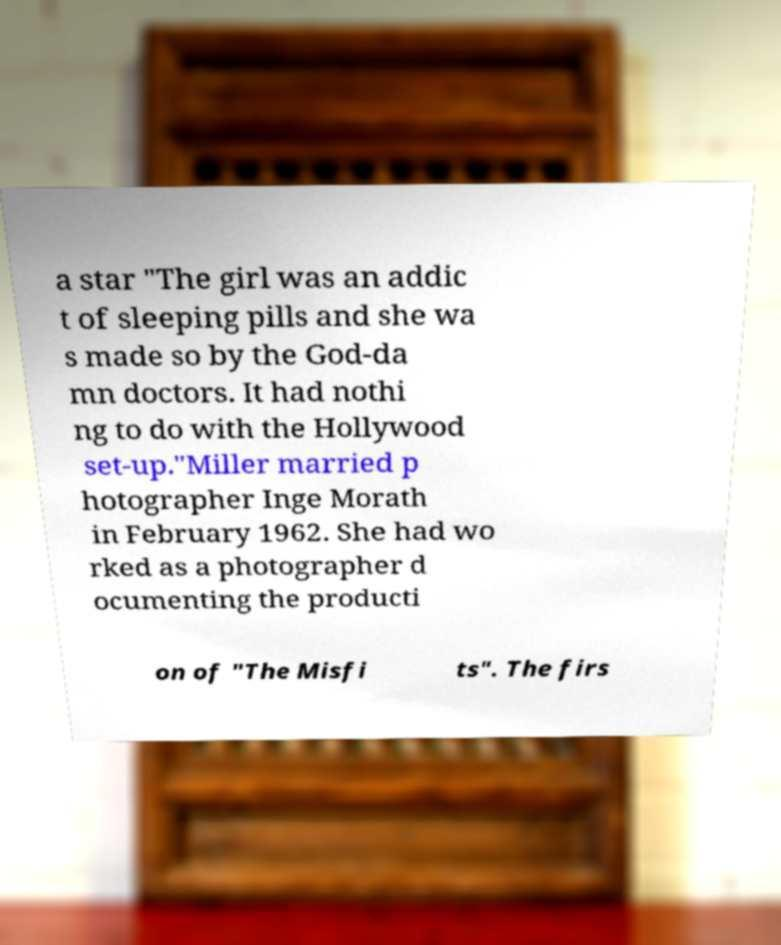Please read and relay the text visible in this image. What does it say? a star "The girl was an addic t of sleeping pills and she wa s made so by the God-da mn doctors. It had nothi ng to do with the Hollywood set-up."Miller married p hotographer Inge Morath in February 1962. She had wo rked as a photographer d ocumenting the producti on of "The Misfi ts". The firs 